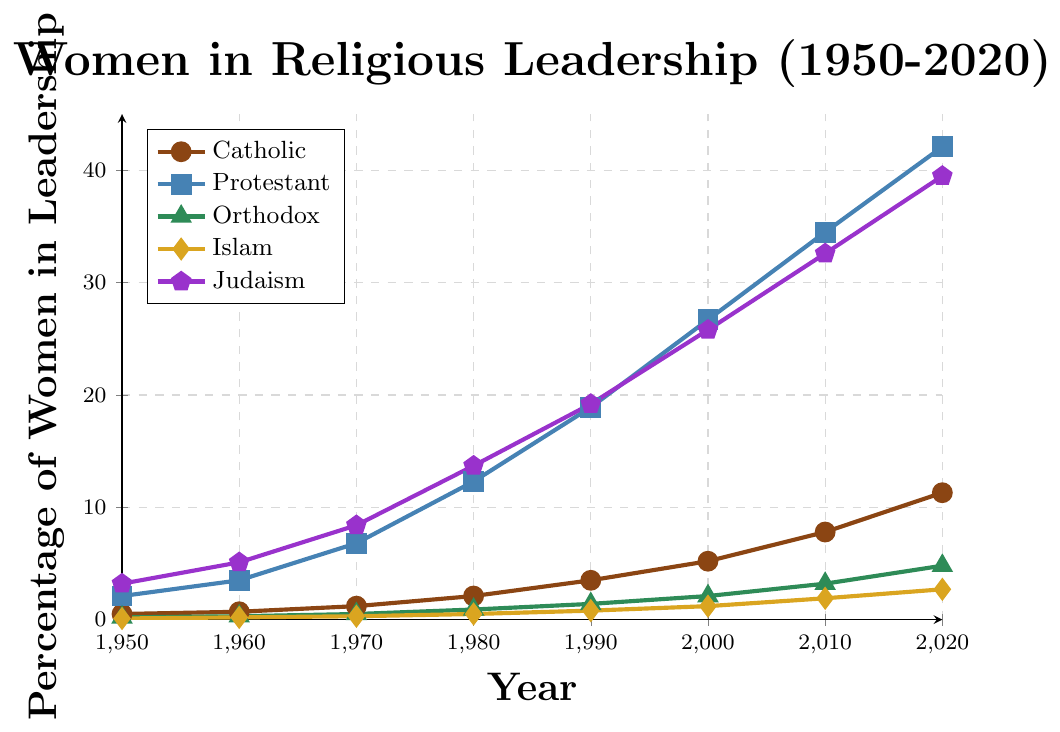What percentage of women held leadership positions in Protestant institutions in 2020? Look at the data point for the Protestant line in 2020 on the y-axis. It shows the percentage as 42.1.
Answer: 42.1 Which religious denomination had the highest percentage of women in leadership roles in 1980? Compare all the data points for the year 1980. The highest percentage is for Judaism at 13.7.
Answer: Judaism In which year did Catholic institutions see women in leadership positions reach 7.8%? Look at the Catholic line and find the year corresponding to the 7.8% mark. It appears in 2010.
Answer: 2010 What is the total increase in the percentage of women in leadership within Orthodox institutions from 1950 to 2020? Subtract the 1950 value from the 2020 value for Orthodox institutions: 4.8 - 0.2 = 4.6.
Answer: 4.6 How do the percentages of women in leadership in Islam in 2000 and Judaism in 1950 compare? Find the data points for Islam (1.2 in 2000) and Judaism (3.2 in 1950) and compare. Judaism at 3.2 is higher than Islam at 1.2.
Answer: Judaism is higher In which two decades did Protestant institutions see the largest increase in women in leadership positions? Calculate the increase for each decade for Protestant institutions and find the two largest: The increases are 4.7 (1970s), 6.6 (1980s), 7.8 (2000s), and 7.6 (2010s). The largest increases are in the 1980s (12.3-6.8) and 2000s (34.5-26.7).
Answer: 1980s and 2000s What is the combined percentage of women in leadership in Catholic, Protestant, and Orthodox institutions in 1990? Add the percentages for Catholic, Protestant, and Orthodox in 1990: 3.5 + 18.9 + 1.4 = 23.8.
Answer: 23.8 Which denomination shows the slowest growth in the percentage of women in leadership from 1950 to 2020? Calculate the growth for each denomination and compare. The growth rates are: Catholic (10.8), Protestant (40), Orthodox (4.6), Islam (2.6), Judaism (36.3). Islam has the slowest growth with an increase of 2.6.
Answer: Islam Which denomination had more than 30% of women in leadership roles first, and in which year? Look at the data to find when each denomination first exceeded 30%. Protestant reached this first in 2000.
Answer: Protestant, 2000 What is the average percentage of women in leadership roles in Catholic institutions during the 1950s and 1960s? Add the values for Catholic institutions in 1950 and 1960, then divide by 2: (0.5 + 0.7) / 2 = 0.6.
Answer: 0.6 